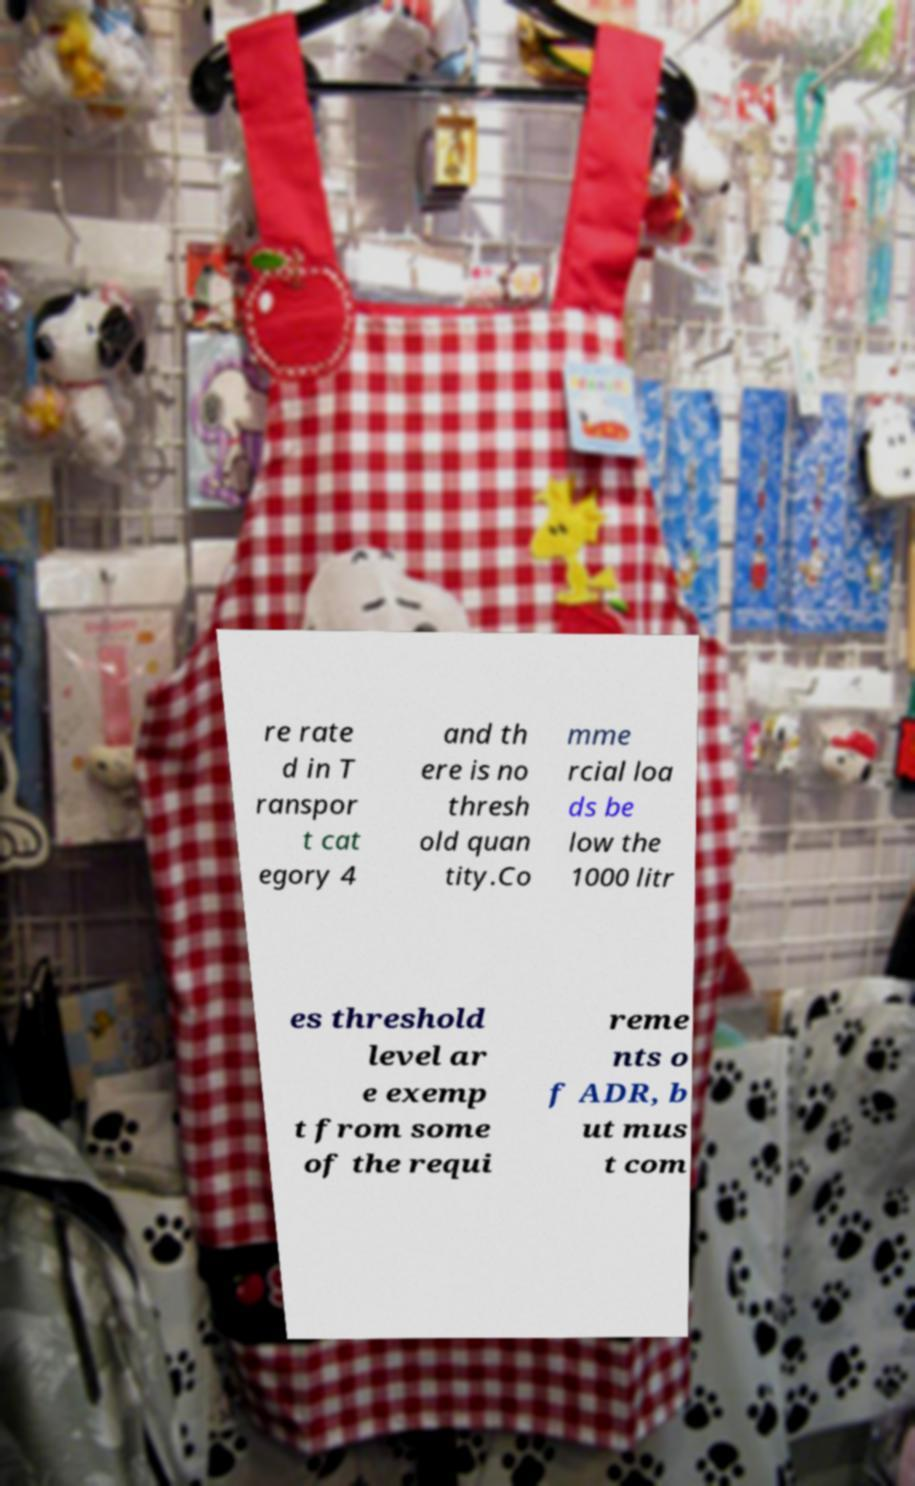What messages or text are displayed in this image? I need them in a readable, typed format. re rate d in T ranspor t cat egory 4 and th ere is no thresh old quan tity.Co mme rcial loa ds be low the 1000 litr es threshold level ar e exemp t from some of the requi reme nts o f ADR, b ut mus t com 